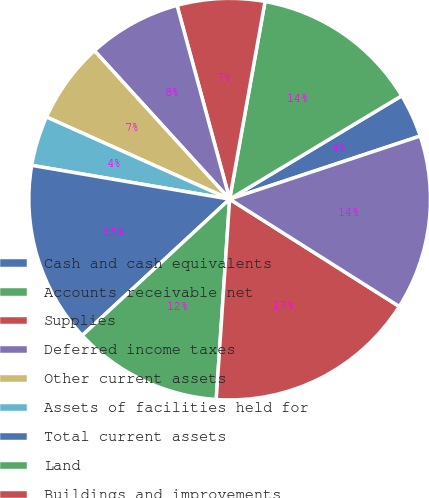<chart> <loc_0><loc_0><loc_500><loc_500><pie_chart><fcel>Cash and cash equivalents<fcel>Accounts receivable net<fcel>Supplies<fcel>Deferred income taxes<fcel>Other current assets<fcel>Assets of facilities held for<fcel>Total current assets<fcel>Land<fcel>Buildings and improvements<fcel>Equipment<nl><fcel>3.52%<fcel>13.57%<fcel>7.04%<fcel>7.54%<fcel>6.53%<fcel>4.02%<fcel>14.57%<fcel>12.06%<fcel>17.09%<fcel>14.07%<nl></chart> 